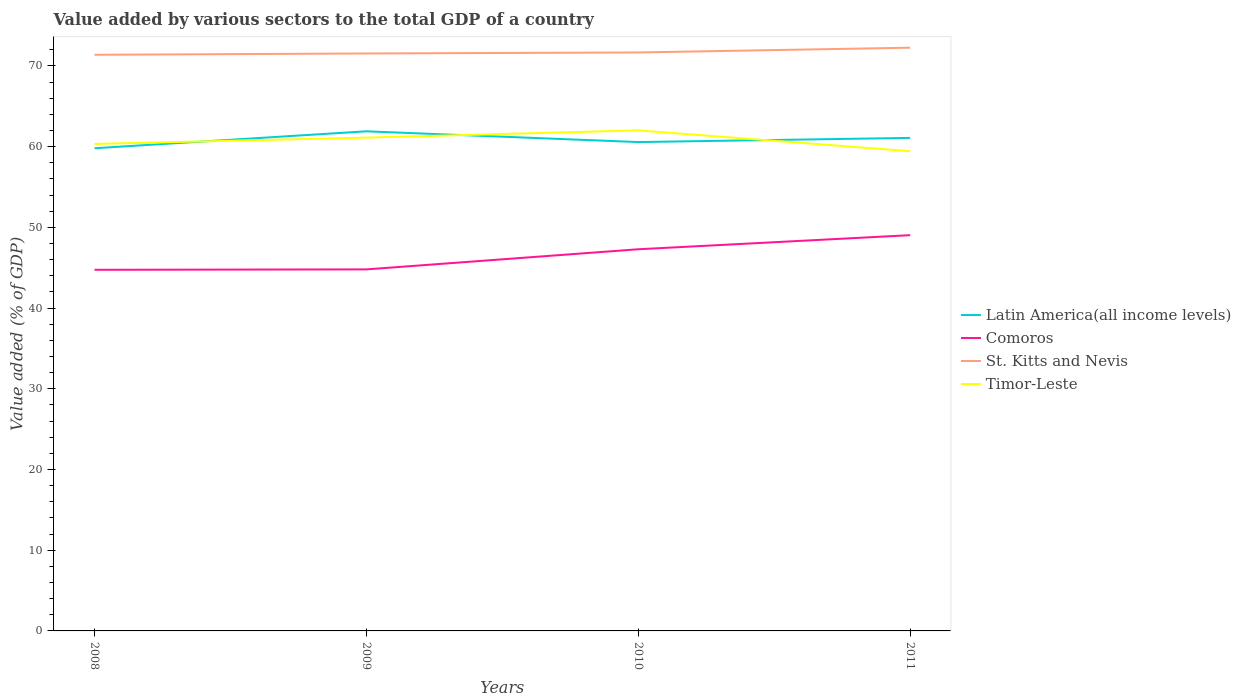How many different coloured lines are there?
Your answer should be very brief. 4. Does the line corresponding to Comoros intersect with the line corresponding to Latin America(all income levels)?
Your answer should be compact. No. Across all years, what is the maximum value added by various sectors to the total GDP in Comoros?
Give a very brief answer. 44.74. What is the total value added by various sectors to the total GDP in Latin America(all income levels) in the graph?
Your answer should be very brief. -1.28. What is the difference between the highest and the second highest value added by various sectors to the total GDP in Comoros?
Ensure brevity in your answer.  4.29. Is the value added by various sectors to the total GDP in St. Kitts and Nevis strictly greater than the value added by various sectors to the total GDP in Latin America(all income levels) over the years?
Make the answer very short. No. How many years are there in the graph?
Keep it short and to the point. 4. What is the difference between two consecutive major ticks on the Y-axis?
Your answer should be very brief. 10. Are the values on the major ticks of Y-axis written in scientific E-notation?
Give a very brief answer. No. Does the graph contain any zero values?
Your response must be concise. No. How are the legend labels stacked?
Your response must be concise. Vertical. What is the title of the graph?
Offer a very short reply. Value added by various sectors to the total GDP of a country. What is the label or title of the X-axis?
Your answer should be compact. Years. What is the label or title of the Y-axis?
Give a very brief answer. Value added (% of GDP). What is the Value added (% of GDP) in Latin America(all income levels) in 2008?
Keep it short and to the point. 59.81. What is the Value added (% of GDP) of Comoros in 2008?
Provide a short and direct response. 44.74. What is the Value added (% of GDP) in St. Kitts and Nevis in 2008?
Your answer should be compact. 71.39. What is the Value added (% of GDP) in Timor-Leste in 2008?
Your answer should be very brief. 60.34. What is the Value added (% of GDP) of Latin America(all income levels) in 2009?
Your response must be concise. 61.91. What is the Value added (% of GDP) of Comoros in 2009?
Offer a terse response. 44.8. What is the Value added (% of GDP) of St. Kitts and Nevis in 2009?
Keep it short and to the point. 71.55. What is the Value added (% of GDP) of Timor-Leste in 2009?
Ensure brevity in your answer.  61.12. What is the Value added (% of GDP) in Latin America(all income levels) in 2010?
Provide a succinct answer. 60.57. What is the Value added (% of GDP) of Comoros in 2010?
Ensure brevity in your answer.  47.29. What is the Value added (% of GDP) in St. Kitts and Nevis in 2010?
Provide a succinct answer. 71.67. What is the Value added (% of GDP) of Timor-Leste in 2010?
Your answer should be very brief. 62.02. What is the Value added (% of GDP) of Latin America(all income levels) in 2011?
Provide a short and direct response. 61.09. What is the Value added (% of GDP) of Comoros in 2011?
Your answer should be compact. 49.04. What is the Value added (% of GDP) of St. Kitts and Nevis in 2011?
Make the answer very short. 72.27. What is the Value added (% of GDP) of Timor-Leste in 2011?
Your answer should be very brief. 59.44. Across all years, what is the maximum Value added (% of GDP) of Latin America(all income levels)?
Make the answer very short. 61.91. Across all years, what is the maximum Value added (% of GDP) of Comoros?
Offer a terse response. 49.04. Across all years, what is the maximum Value added (% of GDP) in St. Kitts and Nevis?
Keep it short and to the point. 72.27. Across all years, what is the maximum Value added (% of GDP) in Timor-Leste?
Ensure brevity in your answer.  62.02. Across all years, what is the minimum Value added (% of GDP) in Latin America(all income levels)?
Offer a terse response. 59.81. Across all years, what is the minimum Value added (% of GDP) of Comoros?
Your answer should be compact. 44.74. Across all years, what is the minimum Value added (% of GDP) of St. Kitts and Nevis?
Provide a succinct answer. 71.39. Across all years, what is the minimum Value added (% of GDP) of Timor-Leste?
Your answer should be compact. 59.44. What is the total Value added (% of GDP) in Latin America(all income levels) in the graph?
Offer a terse response. 243.37. What is the total Value added (% of GDP) in Comoros in the graph?
Your response must be concise. 185.87. What is the total Value added (% of GDP) in St. Kitts and Nevis in the graph?
Keep it short and to the point. 286.88. What is the total Value added (% of GDP) of Timor-Leste in the graph?
Keep it short and to the point. 242.93. What is the difference between the Value added (% of GDP) of Latin America(all income levels) in 2008 and that in 2009?
Make the answer very short. -2.1. What is the difference between the Value added (% of GDP) in Comoros in 2008 and that in 2009?
Make the answer very short. -0.05. What is the difference between the Value added (% of GDP) in St. Kitts and Nevis in 2008 and that in 2009?
Offer a terse response. -0.16. What is the difference between the Value added (% of GDP) of Timor-Leste in 2008 and that in 2009?
Give a very brief answer. -0.78. What is the difference between the Value added (% of GDP) of Latin America(all income levels) in 2008 and that in 2010?
Your response must be concise. -0.77. What is the difference between the Value added (% of GDP) of Comoros in 2008 and that in 2010?
Your response must be concise. -2.55. What is the difference between the Value added (% of GDP) in St. Kitts and Nevis in 2008 and that in 2010?
Offer a very short reply. -0.29. What is the difference between the Value added (% of GDP) in Timor-Leste in 2008 and that in 2010?
Your answer should be compact. -1.68. What is the difference between the Value added (% of GDP) in Latin America(all income levels) in 2008 and that in 2011?
Your answer should be very brief. -1.28. What is the difference between the Value added (% of GDP) in Comoros in 2008 and that in 2011?
Provide a succinct answer. -4.29. What is the difference between the Value added (% of GDP) of St. Kitts and Nevis in 2008 and that in 2011?
Your response must be concise. -0.88. What is the difference between the Value added (% of GDP) in Timor-Leste in 2008 and that in 2011?
Provide a short and direct response. 0.9. What is the difference between the Value added (% of GDP) of Latin America(all income levels) in 2009 and that in 2010?
Your response must be concise. 1.33. What is the difference between the Value added (% of GDP) of Comoros in 2009 and that in 2010?
Your response must be concise. -2.49. What is the difference between the Value added (% of GDP) of St. Kitts and Nevis in 2009 and that in 2010?
Your answer should be very brief. -0.12. What is the difference between the Value added (% of GDP) of Timor-Leste in 2009 and that in 2010?
Offer a very short reply. -0.9. What is the difference between the Value added (% of GDP) of Latin America(all income levels) in 2009 and that in 2011?
Provide a short and direct response. 0.82. What is the difference between the Value added (% of GDP) in Comoros in 2009 and that in 2011?
Offer a terse response. -4.24. What is the difference between the Value added (% of GDP) in St. Kitts and Nevis in 2009 and that in 2011?
Your answer should be compact. -0.72. What is the difference between the Value added (% of GDP) in Timor-Leste in 2009 and that in 2011?
Keep it short and to the point. 1.68. What is the difference between the Value added (% of GDP) in Latin America(all income levels) in 2010 and that in 2011?
Your answer should be compact. -0.52. What is the difference between the Value added (% of GDP) in Comoros in 2010 and that in 2011?
Provide a short and direct response. -1.74. What is the difference between the Value added (% of GDP) in St. Kitts and Nevis in 2010 and that in 2011?
Keep it short and to the point. -0.59. What is the difference between the Value added (% of GDP) of Timor-Leste in 2010 and that in 2011?
Your answer should be very brief. 2.58. What is the difference between the Value added (% of GDP) of Latin America(all income levels) in 2008 and the Value added (% of GDP) of Comoros in 2009?
Your response must be concise. 15.01. What is the difference between the Value added (% of GDP) of Latin America(all income levels) in 2008 and the Value added (% of GDP) of St. Kitts and Nevis in 2009?
Provide a short and direct response. -11.74. What is the difference between the Value added (% of GDP) of Latin America(all income levels) in 2008 and the Value added (% of GDP) of Timor-Leste in 2009?
Give a very brief answer. -1.32. What is the difference between the Value added (% of GDP) in Comoros in 2008 and the Value added (% of GDP) in St. Kitts and Nevis in 2009?
Provide a short and direct response. -26.81. What is the difference between the Value added (% of GDP) of Comoros in 2008 and the Value added (% of GDP) of Timor-Leste in 2009?
Your response must be concise. -16.38. What is the difference between the Value added (% of GDP) of St. Kitts and Nevis in 2008 and the Value added (% of GDP) of Timor-Leste in 2009?
Provide a succinct answer. 10.26. What is the difference between the Value added (% of GDP) in Latin America(all income levels) in 2008 and the Value added (% of GDP) in Comoros in 2010?
Provide a succinct answer. 12.52. What is the difference between the Value added (% of GDP) of Latin America(all income levels) in 2008 and the Value added (% of GDP) of St. Kitts and Nevis in 2010?
Offer a terse response. -11.87. What is the difference between the Value added (% of GDP) in Latin America(all income levels) in 2008 and the Value added (% of GDP) in Timor-Leste in 2010?
Make the answer very short. -2.21. What is the difference between the Value added (% of GDP) of Comoros in 2008 and the Value added (% of GDP) of St. Kitts and Nevis in 2010?
Your answer should be very brief. -26.93. What is the difference between the Value added (% of GDP) of Comoros in 2008 and the Value added (% of GDP) of Timor-Leste in 2010?
Offer a very short reply. -17.28. What is the difference between the Value added (% of GDP) of St. Kitts and Nevis in 2008 and the Value added (% of GDP) of Timor-Leste in 2010?
Your response must be concise. 9.37. What is the difference between the Value added (% of GDP) of Latin America(all income levels) in 2008 and the Value added (% of GDP) of Comoros in 2011?
Your response must be concise. 10.77. What is the difference between the Value added (% of GDP) of Latin America(all income levels) in 2008 and the Value added (% of GDP) of St. Kitts and Nevis in 2011?
Provide a short and direct response. -12.46. What is the difference between the Value added (% of GDP) in Latin America(all income levels) in 2008 and the Value added (% of GDP) in Timor-Leste in 2011?
Offer a terse response. 0.37. What is the difference between the Value added (% of GDP) in Comoros in 2008 and the Value added (% of GDP) in St. Kitts and Nevis in 2011?
Keep it short and to the point. -27.52. What is the difference between the Value added (% of GDP) in Comoros in 2008 and the Value added (% of GDP) in Timor-Leste in 2011?
Give a very brief answer. -14.7. What is the difference between the Value added (% of GDP) in St. Kitts and Nevis in 2008 and the Value added (% of GDP) in Timor-Leste in 2011?
Your response must be concise. 11.95. What is the difference between the Value added (% of GDP) in Latin America(all income levels) in 2009 and the Value added (% of GDP) in Comoros in 2010?
Provide a succinct answer. 14.61. What is the difference between the Value added (% of GDP) of Latin America(all income levels) in 2009 and the Value added (% of GDP) of St. Kitts and Nevis in 2010?
Offer a very short reply. -9.77. What is the difference between the Value added (% of GDP) of Latin America(all income levels) in 2009 and the Value added (% of GDP) of Timor-Leste in 2010?
Provide a succinct answer. -0.12. What is the difference between the Value added (% of GDP) in Comoros in 2009 and the Value added (% of GDP) in St. Kitts and Nevis in 2010?
Provide a succinct answer. -26.88. What is the difference between the Value added (% of GDP) of Comoros in 2009 and the Value added (% of GDP) of Timor-Leste in 2010?
Ensure brevity in your answer.  -17.23. What is the difference between the Value added (% of GDP) of St. Kitts and Nevis in 2009 and the Value added (% of GDP) of Timor-Leste in 2010?
Ensure brevity in your answer.  9.53. What is the difference between the Value added (% of GDP) in Latin America(all income levels) in 2009 and the Value added (% of GDP) in Comoros in 2011?
Your response must be concise. 12.87. What is the difference between the Value added (% of GDP) in Latin America(all income levels) in 2009 and the Value added (% of GDP) in St. Kitts and Nevis in 2011?
Make the answer very short. -10.36. What is the difference between the Value added (% of GDP) of Latin America(all income levels) in 2009 and the Value added (% of GDP) of Timor-Leste in 2011?
Give a very brief answer. 2.47. What is the difference between the Value added (% of GDP) of Comoros in 2009 and the Value added (% of GDP) of St. Kitts and Nevis in 2011?
Your answer should be very brief. -27.47. What is the difference between the Value added (% of GDP) of Comoros in 2009 and the Value added (% of GDP) of Timor-Leste in 2011?
Offer a very short reply. -14.64. What is the difference between the Value added (% of GDP) in St. Kitts and Nevis in 2009 and the Value added (% of GDP) in Timor-Leste in 2011?
Your response must be concise. 12.11. What is the difference between the Value added (% of GDP) in Latin America(all income levels) in 2010 and the Value added (% of GDP) in Comoros in 2011?
Your answer should be compact. 11.54. What is the difference between the Value added (% of GDP) of Latin America(all income levels) in 2010 and the Value added (% of GDP) of St. Kitts and Nevis in 2011?
Offer a terse response. -11.69. What is the difference between the Value added (% of GDP) in Latin America(all income levels) in 2010 and the Value added (% of GDP) in Timor-Leste in 2011?
Provide a short and direct response. 1.13. What is the difference between the Value added (% of GDP) in Comoros in 2010 and the Value added (% of GDP) in St. Kitts and Nevis in 2011?
Keep it short and to the point. -24.98. What is the difference between the Value added (% of GDP) of Comoros in 2010 and the Value added (% of GDP) of Timor-Leste in 2011?
Ensure brevity in your answer.  -12.15. What is the difference between the Value added (% of GDP) of St. Kitts and Nevis in 2010 and the Value added (% of GDP) of Timor-Leste in 2011?
Make the answer very short. 12.23. What is the average Value added (% of GDP) in Latin America(all income levels) per year?
Provide a succinct answer. 60.84. What is the average Value added (% of GDP) in Comoros per year?
Offer a terse response. 46.47. What is the average Value added (% of GDP) of St. Kitts and Nevis per year?
Offer a terse response. 71.72. What is the average Value added (% of GDP) in Timor-Leste per year?
Provide a succinct answer. 60.73. In the year 2008, what is the difference between the Value added (% of GDP) of Latin America(all income levels) and Value added (% of GDP) of Comoros?
Make the answer very short. 15.06. In the year 2008, what is the difference between the Value added (% of GDP) in Latin America(all income levels) and Value added (% of GDP) in St. Kitts and Nevis?
Ensure brevity in your answer.  -11.58. In the year 2008, what is the difference between the Value added (% of GDP) in Latin America(all income levels) and Value added (% of GDP) in Timor-Leste?
Keep it short and to the point. -0.54. In the year 2008, what is the difference between the Value added (% of GDP) in Comoros and Value added (% of GDP) in St. Kitts and Nevis?
Offer a very short reply. -26.64. In the year 2008, what is the difference between the Value added (% of GDP) in Comoros and Value added (% of GDP) in Timor-Leste?
Give a very brief answer. -15.6. In the year 2008, what is the difference between the Value added (% of GDP) of St. Kitts and Nevis and Value added (% of GDP) of Timor-Leste?
Make the answer very short. 11.04. In the year 2009, what is the difference between the Value added (% of GDP) in Latin America(all income levels) and Value added (% of GDP) in Comoros?
Your answer should be very brief. 17.11. In the year 2009, what is the difference between the Value added (% of GDP) of Latin America(all income levels) and Value added (% of GDP) of St. Kitts and Nevis?
Ensure brevity in your answer.  -9.65. In the year 2009, what is the difference between the Value added (% of GDP) of Latin America(all income levels) and Value added (% of GDP) of Timor-Leste?
Make the answer very short. 0.78. In the year 2009, what is the difference between the Value added (% of GDP) of Comoros and Value added (% of GDP) of St. Kitts and Nevis?
Your answer should be compact. -26.75. In the year 2009, what is the difference between the Value added (% of GDP) of Comoros and Value added (% of GDP) of Timor-Leste?
Give a very brief answer. -16.33. In the year 2009, what is the difference between the Value added (% of GDP) of St. Kitts and Nevis and Value added (% of GDP) of Timor-Leste?
Your answer should be very brief. 10.43. In the year 2010, what is the difference between the Value added (% of GDP) of Latin America(all income levels) and Value added (% of GDP) of Comoros?
Provide a short and direct response. 13.28. In the year 2010, what is the difference between the Value added (% of GDP) of Latin America(all income levels) and Value added (% of GDP) of St. Kitts and Nevis?
Ensure brevity in your answer.  -11.1. In the year 2010, what is the difference between the Value added (% of GDP) of Latin America(all income levels) and Value added (% of GDP) of Timor-Leste?
Ensure brevity in your answer.  -1.45. In the year 2010, what is the difference between the Value added (% of GDP) of Comoros and Value added (% of GDP) of St. Kitts and Nevis?
Provide a short and direct response. -24.38. In the year 2010, what is the difference between the Value added (% of GDP) in Comoros and Value added (% of GDP) in Timor-Leste?
Provide a short and direct response. -14.73. In the year 2010, what is the difference between the Value added (% of GDP) in St. Kitts and Nevis and Value added (% of GDP) in Timor-Leste?
Ensure brevity in your answer.  9.65. In the year 2011, what is the difference between the Value added (% of GDP) in Latin America(all income levels) and Value added (% of GDP) in Comoros?
Provide a succinct answer. 12.05. In the year 2011, what is the difference between the Value added (% of GDP) in Latin America(all income levels) and Value added (% of GDP) in St. Kitts and Nevis?
Make the answer very short. -11.18. In the year 2011, what is the difference between the Value added (% of GDP) in Latin America(all income levels) and Value added (% of GDP) in Timor-Leste?
Keep it short and to the point. 1.65. In the year 2011, what is the difference between the Value added (% of GDP) in Comoros and Value added (% of GDP) in St. Kitts and Nevis?
Provide a succinct answer. -23.23. In the year 2011, what is the difference between the Value added (% of GDP) of Comoros and Value added (% of GDP) of Timor-Leste?
Make the answer very short. -10.4. In the year 2011, what is the difference between the Value added (% of GDP) of St. Kitts and Nevis and Value added (% of GDP) of Timor-Leste?
Keep it short and to the point. 12.83. What is the ratio of the Value added (% of GDP) of Latin America(all income levels) in 2008 to that in 2009?
Your response must be concise. 0.97. What is the ratio of the Value added (% of GDP) in Timor-Leste in 2008 to that in 2009?
Offer a very short reply. 0.99. What is the ratio of the Value added (% of GDP) in Latin America(all income levels) in 2008 to that in 2010?
Give a very brief answer. 0.99. What is the ratio of the Value added (% of GDP) in Comoros in 2008 to that in 2010?
Provide a succinct answer. 0.95. What is the ratio of the Value added (% of GDP) in St. Kitts and Nevis in 2008 to that in 2010?
Your answer should be compact. 1. What is the ratio of the Value added (% of GDP) of Comoros in 2008 to that in 2011?
Give a very brief answer. 0.91. What is the ratio of the Value added (% of GDP) of Timor-Leste in 2008 to that in 2011?
Give a very brief answer. 1.02. What is the ratio of the Value added (% of GDP) in Latin America(all income levels) in 2009 to that in 2010?
Your response must be concise. 1.02. What is the ratio of the Value added (% of GDP) in Comoros in 2009 to that in 2010?
Provide a succinct answer. 0.95. What is the ratio of the Value added (% of GDP) of St. Kitts and Nevis in 2009 to that in 2010?
Your answer should be compact. 1. What is the ratio of the Value added (% of GDP) of Timor-Leste in 2009 to that in 2010?
Give a very brief answer. 0.99. What is the ratio of the Value added (% of GDP) in Latin America(all income levels) in 2009 to that in 2011?
Provide a short and direct response. 1.01. What is the ratio of the Value added (% of GDP) of Comoros in 2009 to that in 2011?
Ensure brevity in your answer.  0.91. What is the ratio of the Value added (% of GDP) in Timor-Leste in 2009 to that in 2011?
Offer a terse response. 1.03. What is the ratio of the Value added (% of GDP) in Latin America(all income levels) in 2010 to that in 2011?
Keep it short and to the point. 0.99. What is the ratio of the Value added (% of GDP) in Comoros in 2010 to that in 2011?
Keep it short and to the point. 0.96. What is the ratio of the Value added (% of GDP) in Timor-Leste in 2010 to that in 2011?
Give a very brief answer. 1.04. What is the difference between the highest and the second highest Value added (% of GDP) of Latin America(all income levels)?
Offer a terse response. 0.82. What is the difference between the highest and the second highest Value added (% of GDP) of Comoros?
Your response must be concise. 1.74. What is the difference between the highest and the second highest Value added (% of GDP) in St. Kitts and Nevis?
Make the answer very short. 0.59. What is the difference between the highest and the second highest Value added (% of GDP) in Timor-Leste?
Ensure brevity in your answer.  0.9. What is the difference between the highest and the lowest Value added (% of GDP) in Latin America(all income levels)?
Ensure brevity in your answer.  2.1. What is the difference between the highest and the lowest Value added (% of GDP) in Comoros?
Offer a very short reply. 4.29. What is the difference between the highest and the lowest Value added (% of GDP) of St. Kitts and Nevis?
Your response must be concise. 0.88. What is the difference between the highest and the lowest Value added (% of GDP) of Timor-Leste?
Offer a very short reply. 2.58. 